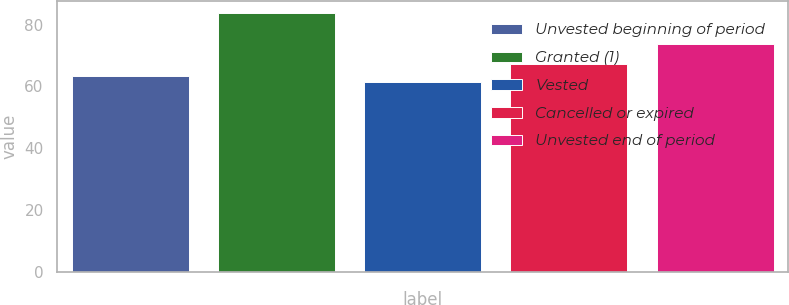Convert chart. <chart><loc_0><loc_0><loc_500><loc_500><bar_chart><fcel>Unvested beginning of period<fcel>Granted (1)<fcel>Vested<fcel>Cancelled or expired<fcel>Unvested end of period<nl><fcel>63.53<fcel>83.58<fcel>61.3<fcel>67.22<fcel>73.81<nl></chart> 